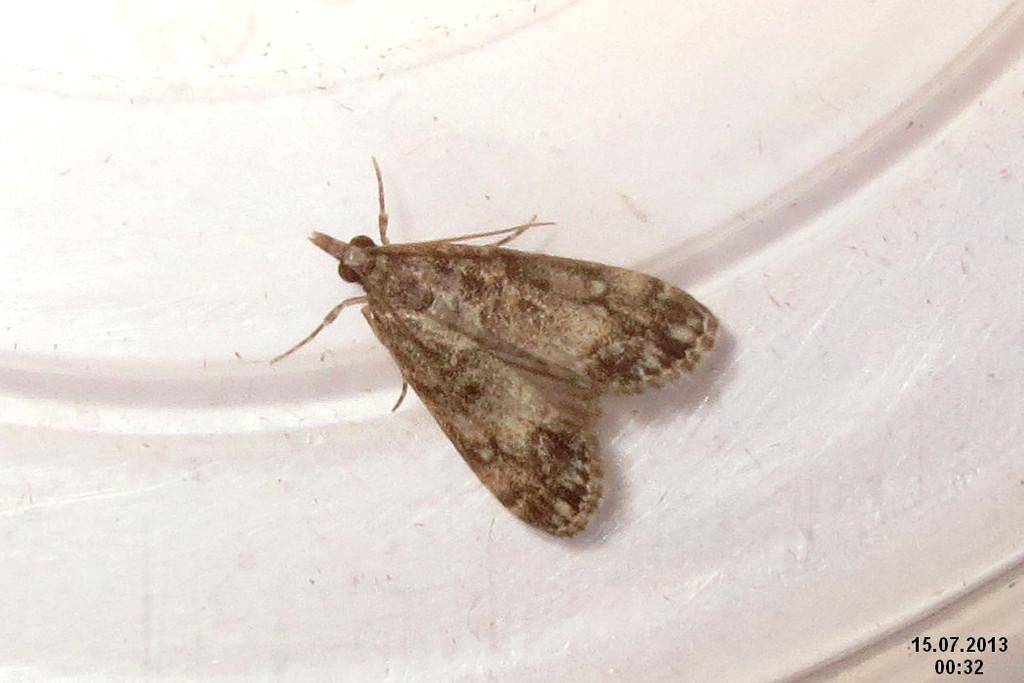What type of insect is in the picture? There is a small brown butterfly in the picture. What is the butterfly sitting on? The butterfly is sitting on a white surface. How many horses are visible in the picture? There are no horses present in the picture; it features a small brown butterfly sitting on a white surface. What type of hose can be seen in the picture? There is no hose present in the picture; it only shows a small brown butterfly sitting on a white surface. 